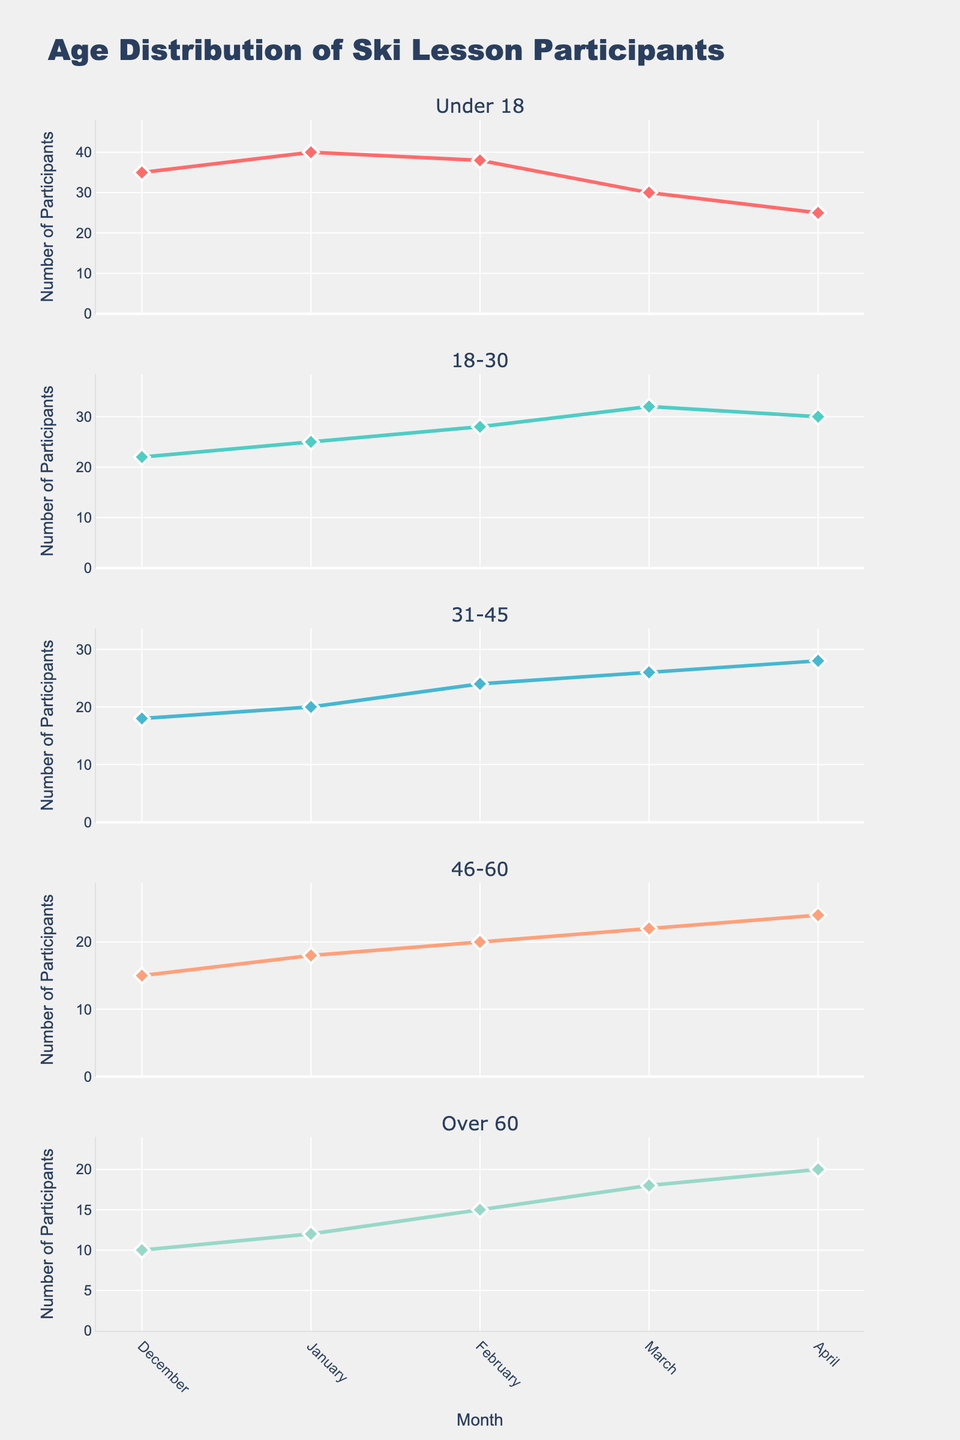What is the title of the figure? The title of the figure is located at the top and is labeled "Wellness Retreat Experience Ratings" in the layout.
Answer: Wellness Retreat Experience Ratings Which aspect received the highest number of 'Excellent' ratings? To find the aspect with the highest number of 'Excellent' ratings, review the bar charts for all aspects. Massage Services has 55 'Excellent' ratings, the most among the aspects.
Answer: Massage Services How many 'Poor' ratings did the Food aspect receive? Look at the bar corresponding to the Food aspect and see the 'Poor' category. The Food aspect received 5 'Poor' ratings, as indicated by the height of the respective bar.
Answer: 5 Among the listed wellness retreat experiences, which aspects are rated better than 'Average' by more participants than 'Poor'? Identify which aspects have bars showing higher values in categories 'Excellent' and 'Good' than 'Poor'. All aspects (Accommodation, Food, Activities, Massage Services, Yoga Sessions, Meditation Classes, Nature Walks, Spa Treatments) fit this criterion since 'Excellent' and 'Good' are higher.
Answer: All aspects How do the 'Excellent' ratings compare between Accommodation and Yoga Sessions? To find this, check the height of the 'Excellent' bar in both the Accommodation and Yoga Sessions subplots. Accommodation has 45 'Excellent' ratings while Yoga Sessions have 48. Yoga Sessions have slightly more 'Excellent' ratings than Accommodation.
Answer: Yoga Sessions Which aspect has the most consistent ratings across 'Excellent,' 'Good,' 'Average,' and 'Poor' categories? Consistent ratings imply relatively similar bar heights across all categories. Nature Walks have values of 38, 40, 17, and 5, which are more evenly distributed compared to other aspects.
Answer: Nature Walks What is the difference between 'Excellent' ratings for Spa Treatments and Meditation Classes? Look at the 'Excellent' bars for both aspects. Spa Treatments have 52 'Excellent' ratings, while Meditation Classes have 42. The difference is 52 - 42 = 10.
Answer: 10 Which categories have more than 50 participants rating 'Excellent'? Examine which aspects have 'Excellent' bars exceeding 50 units in height. Massage Services has 55 and is the only category that fulfills this criterion.
Answer: Massage Services 